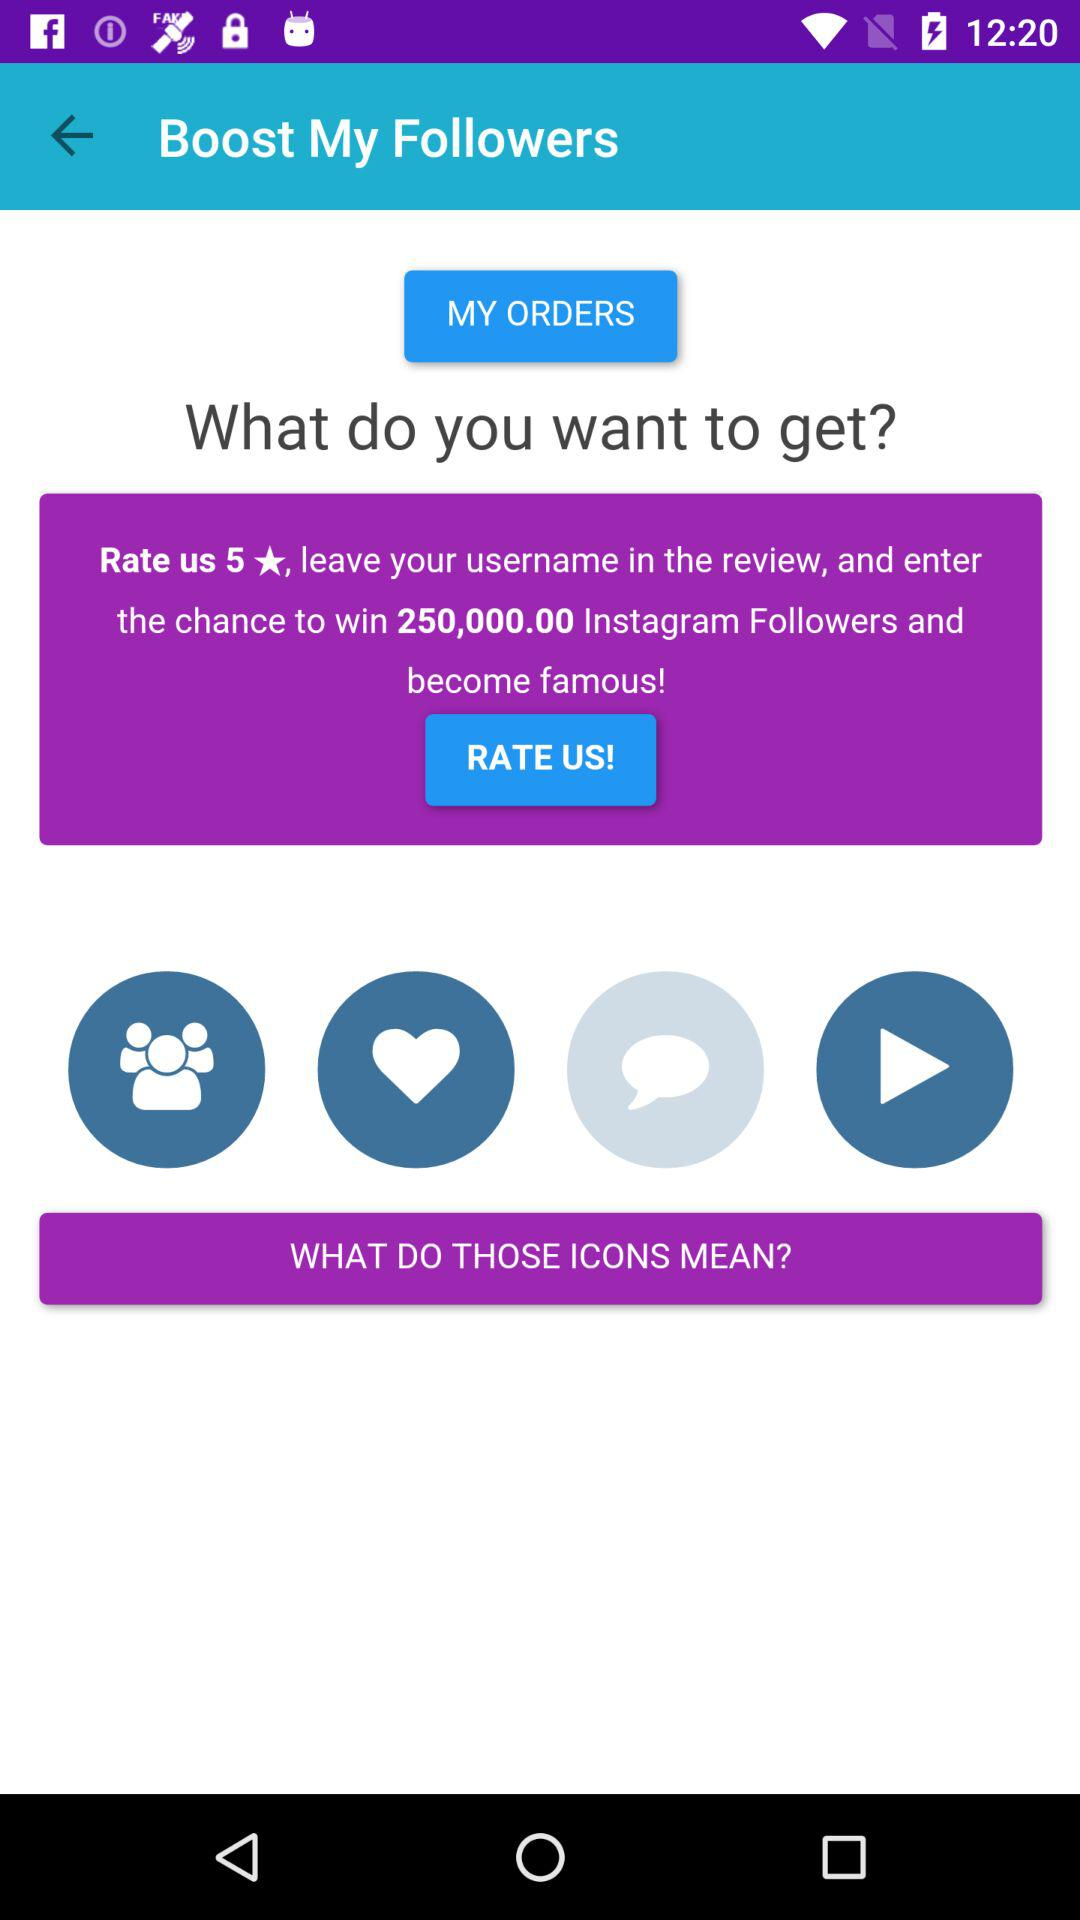How many orders are there?
When the provided information is insufficient, respond with <no answer>. <no answer> 